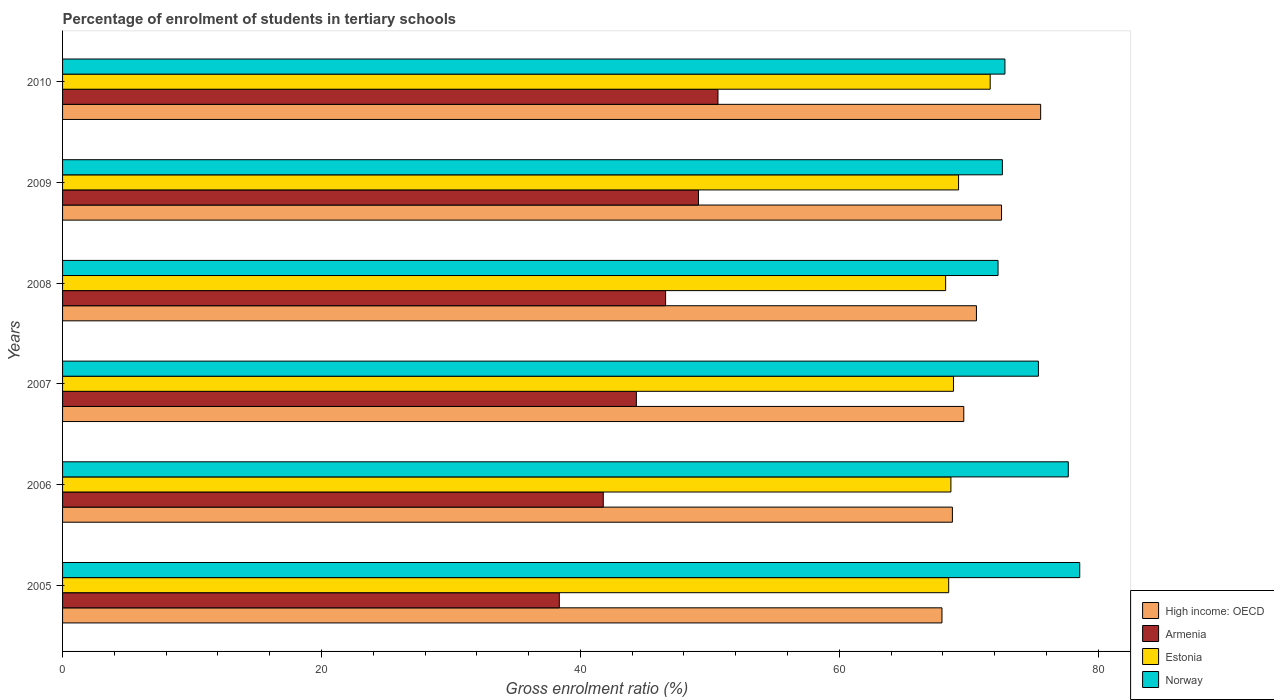How many groups of bars are there?
Provide a short and direct response. 6. Are the number of bars per tick equal to the number of legend labels?
Keep it short and to the point. Yes. Are the number of bars on each tick of the Y-axis equal?
Your answer should be compact. Yes. How many bars are there on the 6th tick from the top?
Your answer should be very brief. 4. How many bars are there on the 5th tick from the bottom?
Your answer should be very brief. 4. What is the label of the 2nd group of bars from the top?
Your answer should be very brief. 2009. In how many cases, is the number of bars for a given year not equal to the number of legend labels?
Your answer should be compact. 0. What is the percentage of students enrolled in tertiary schools in Armenia in 2008?
Your answer should be very brief. 46.58. Across all years, what is the maximum percentage of students enrolled in tertiary schools in High income: OECD?
Your answer should be very brief. 75.55. Across all years, what is the minimum percentage of students enrolled in tertiary schools in Estonia?
Ensure brevity in your answer.  68.21. In which year was the percentage of students enrolled in tertiary schools in Armenia maximum?
Your answer should be compact. 2010. In which year was the percentage of students enrolled in tertiary schools in Armenia minimum?
Keep it short and to the point. 2005. What is the total percentage of students enrolled in tertiary schools in Norway in the graph?
Keep it short and to the point. 449.27. What is the difference between the percentage of students enrolled in tertiary schools in Armenia in 2006 and that in 2009?
Make the answer very short. -7.35. What is the difference between the percentage of students enrolled in tertiary schools in Armenia in 2009 and the percentage of students enrolled in tertiary schools in Norway in 2008?
Offer a terse response. -23.14. What is the average percentage of students enrolled in tertiary schools in Estonia per year?
Provide a succinct answer. 69.16. In the year 2007, what is the difference between the percentage of students enrolled in tertiary schools in Estonia and percentage of students enrolled in tertiary schools in High income: OECD?
Your response must be concise. -0.8. In how many years, is the percentage of students enrolled in tertiary schools in High income: OECD greater than 48 %?
Make the answer very short. 6. What is the ratio of the percentage of students enrolled in tertiary schools in Norway in 2005 to that in 2006?
Your answer should be compact. 1.01. Is the percentage of students enrolled in tertiary schools in Armenia in 2008 less than that in 2009?
Your answer should be very brief. Yes. What is the difference between the highest and the second highest percentage of students enrolled in tertiary schools in High income: OECD?
Ensure brevity in your answer.  3.02. What is the difference between the highest and the lowest percentage of students enrolled in tertiary schools in High income: OECD?
Offer a terse response. 7.62. Is the sum of the percentage of students enrolled in tertiary schools in Armenia in 2006 and 2008 greater than the maximum percentage of students enrolled in tertiary schools in Norway across all years?
Offer a very short reply. Yes. Is it the case that in every year, the sum of the percentage of students enrolled in tertiary schools in Armenia and percentage of students enrolled in tertiary schools in Norway is greater than the sum of percentage of students enrolled in tertiary schools in High income: OECD and percentage of students enrolled in tertiary schools in Estonia?
Give a very brief answer. No. What does the 4th bar from the top in 2010 represents?
Provide a succinct answer. High income: OECD. What does the 3rd bar from the bottom in 2007 represents?
Keep it short and to the point. Estonia. Is it the case that in every year, the sum of the percentage of students enrolled in tertiary schools in Armenia and percentage of students enrolled in tertiary schools in Estonia is greater than the percentage of students enrolled in tertiary schools in Norway?
Give a very brief answer. Yes. How many years are there in the graph?
Provide a short and direct response. 6. Are the values on the major ticks of X-axis written in scientific E-notation?
Give a very brief answer. No. Does the graph contain any zero values?
Give a very brief answer. No. Where does the legend appear in the graph?
Keep it short and to the point. Bottom right. How many legend labels are there?
Provide a succinct answer. 4. How are the legend labels stacked?
Provide a succinct answer. Vertical. What is the title of the graph?
Offer a terse response. Percentage of enrolment of students in tertiary schools. What is the label or title of the X-axis?
Your response must be concise. Gross enrolment ratio (%). What is the Gross enrolment ratio (%) of High income: OECD in 2005?
Provide a succinct answer. 67.93. What is the Gross enrolment ratio (%) of Armenia in 2005?
Offer a terse response. 38.37. What is the Gross enrolment ratio (%) of Estonia in 2005?
Ensure brevity in your answer.  68.45. What is the Gross enrolment ratio (%) in Norway in 2005?
Ensure brevity in your answer.  78.57. What is the Gross enrolment ratio (%) of High income: OECD in 2006?
Make the answer very short. 68.73. What is the Gross enrolment ratio (%) in Armenia in 2006?
Offer a very short reply. 41.77. What is the Gross enrolment ratio (%) in Estonia in 2006?
Your answer should be very brief. 68.62. What is the Gross enrolment ratio (%) in Norway in 2006?
Give a very brief answer. 77.68. What is the Gross enrolment ratio (%) in High income: OECD in 2007?
Offer a very short reply. 69.61. What is the Gross enrolment ratio (%) in Armenia in 2007?
Ensure brevity in your answer.  44.32. What is the Gross enrolment ratio (%) of Estonia in 2007?
Offer a very short reply. 68.82. What is the Gross enrolment ratio (%) in Norway in 2007?
Provide a succinct answer. 75.38. What is the Gross enrolment ratio (%) in High income: OECD in 2008?
Ensure brevity in your answer.  70.59. What is the Gross enrolment ratio (%) in Armenia in 2008?
Make the answer very short. 46.58. What is the Gross enrolment ratio (%) of Estonia in 2008?
Your answer should be compact. 68.21. What is the Gross enrolment ratio (%) in Norway in 2008?
Your answer should be very brief. 72.26. What is the Gross enrolment ratio (%) of High income: OECD in 2009?
Offer a very short reply. 72.53. What is the Gross enrolment ratio (%) of Armenia in 2009?
Provide a succinct answer. 49.12. What is the Gross enrolment ratio (%) of Estonia in 2009?
Your answer should be compact. 69.21. What is the Gross enrolment ratio (%) in Norway in 2009?
Your response must be concise. 72.59. What is the Gross enrolment ratio (%) in High income: OECD in 2010?
Provide a short and direct response. 75.55. What is the Gross enrolment ratio (%) in Armenia in 2010?
Ensure brevity in your answer.  50.62. What is the Gross enrolment ratio (%) of Estonia in 2010?
Make the answer very short. 71.65. What is the Gross enrolment ratio (%) of Norway in 2010?
Your answer should be compact. 72.79. Across all years, what is the maximum Gross enrolment ratio (%) in High income: OECD?
Give a very brief answer. 75.55. Across all years, what is the maximum Gross enrolment ratio (%) in Armenia?
Offer a very short reply. 50.62. Across all years, what is the maximum Gross enrolment ratio (%) of Estonia?
Your answer should be compact. 71.65. Across all years, what is the maximum Gross enrolment ratio (%) of Norway?
Offer a very short reply. 78.57. Across all years, what is the minimum Gross enrolment ratio (%) of High income: OECD?
Provide a short and direct response. 67.93. Across all years, what is the minimum Gross enrolment ratio (%) in Armenia?
Provide a succinct answer. 38.37. Across all years, what is the minimum Gross enrolment ratio (%) of Estonia?
Your answer should be very brief. 68.21. Across all years, what is the minimum Gross enrolment ratio (%) in Norway?
Ensure brevity in your answer.  72.26. What is the total Gross enrolment ratio (%) of High income: OECD in the graph?
Offer a terse response. 424.94. What is the total Gross enrolment ratio (%) in Armenia in the graph?
Give a very brief answer. 270.78. What is the total Gross enrolment ratio (%) in Estonia in the graph?
Provide a succinct answer. 414.95. What is the total Gross enrolment ratio (%) in Norway in the graph?
Ensure brevity in your answer.  449.27. What is the difference between the Gross enrolment ratio (%) in High income: OECD in 2005 and that in 2006?
Offer a very short reply. -0.81. What is the difference between the Gross enrolment ratio (%) of Armenia in 2005 and that in 2006?
Provide a short and direct response. -3.4. What is the difference between the Gross enrolment ratio (%) in Estonia in 2005 and that in 2006?
Your answer should be very brief. -0.17. What is the difference between the Gross enrolment ratio (%) of Norway in 2005 and that in 2006?
Your answer should be very brief. 0.88. What is the difference between the Gross enrolment ratio (%) of High income: OECD in 2005 and that in 2007?
Offer a very short reply. -1.69. What is the difference between the Gross enrolment ratio (%) of Armenia in 2005 and that in 2007?
Keep it short and to the point. -5.95. What is the difference between the Gross enrolment ratio (%) of Estonia in 2005 and that in 2007?
Offer a terse response. -0.37. What is the difference between the Gross enrolment ratio (%) in Norway in 2005 and that in 2007?
Ensure brevity in your answer.  3.19. What is the difference between the Gross enrolment ratio (%) in High income: OECD in 2005 and that in 2008?
Offer a very short reply. -2.66. What is the difference between the Gross enrolment ratio (%) of Armenia in 2005 and that in 2008?
Provide a succinct answer. -8.21. What is the difference between the Gross enrolment ratio (%) of Estonia in 2005 and that in 2008?
Give a very brief answer. 0.24. What is the difference between the Gross enrolment ratio (%) in Norway in 2005 and that in 2008?
Your response must be concise. 6.31. What is the difference between the Gross enrolment ratio (%) in High income: OECD in 2005 and that in 2009?
Provide a succinct answer. -4.6. What is the difference between the Gross enrolment ratio (%) in Armenia in 2005 and that in 2009?
Provide a short and direct response. -10.75. What is the difference between the Gross enrolment ratio (%) of Estonia in 2005 and that in 2009?
Your answer should be very brief. -0.76. What is the difference between the Gross enrolment ratio (%) in Norway in 2005 and that in 2009?
Ensure brevity in your answer.  5.98. What is the difference between the Gross enrolment ratio (%) of High income: OECD in 2005 and that in 2010?
Provide a succinct answer. -7.62. What is the difference between the Gross enrolment ratio (%) of Armenia in 2005 and that in 2010?
Offer a very short reply. -12.26. What is the difference between the Gross enrolment ratio (%) in Estonia in 2005 and that in 2010?
Keep it short and to the point. -3.21. What is the difference between the Gross enrolment ratio (%) in Norway in 2005 and that in 2010?
Ensure brevity in your answer.  5.78. What is the difference between the Gross enrolment ratio (%) in High income: OECD in 2006 and that in 2007?
Give a very brief answer. -0.88. What is the difference between the Gross enrolment ratio (%) in Armenia in 2006 and that in 2007?
Make the answer very short. -2.56. What is the difference between the Gross enrolment ratio (%) in Estonia in 2006 and that in 2007?
Give a very brief answer. -0.2. What is the difference between the Gross enrolment ratio (%) in Norway in 2006 and that in 2007?
Offer a very short reply. 2.31. What is the difference between the Gross enrolment ratio (%) in High income: OECD in 2006 and that in 2008?
Keep it short and to the point. -1.86. What is the difference between the Gross enrolment ratio (%) in Armenia in 2006 and that in 2008?
Offer a terse response. -4.82. What is the difference between the Gross enrolment ratio (%) of Estonia in 2006 and that in 2008?
Your answer should be very brief. 0.41. What is the difference between the Gross enrolment ratio (%) of Norway in 2006 and that in 2008?
Give a very brief answer. 5.43. What is the difference between the Gross enrolment ratio (%) of High income: OECD in 2006 and that in 2009?
Keep it short and to the point. -3.8. What is the difference between the Gross enrolment ratio (%) of Armenia in 2006 and that in 2009?
Your response must be concise. -7.35. What is the difference between the Gross enrolment ratio (%) in Estonia in 2006 and that in 2009?
Your answer should be very brief. -0.59. What is the difference between the Gross enrolment ratio (%) in Norway in 2006 and that in 2009?
Offer a terse response. 5.09. What is the difference between the Gross enrolment ratio (%) in High income: OECD in 2006 and that in 2010?
Your answer should be compact. -6.82. What is the difference between the Gross enrolment ratio (%) in Armenia in 2006 and that in 2010?
Provide a short and direct response. -8.86. What is the difference between the Gross enrolment ratio (%) in Estonia in 2006 and that in 2010?
Your answer should be compact. -3.03. What is the difference between the Gross enrolment ratio (%) of Norway in 2006 and that in 2010?
Offer a very short reply. 4.89. What is the difference between the Gross enrolment ratio (%) in High income: OECD in 2007 and that in 2008?
Your answer should be compact. -0.98. What is the difference between the Gross enrolment ratio (%) of Armenia in 2007 and that in 2008?
Keep it short and to the point. -2.26. What is the difference between the Gross enrolment ratio (%) in Estonia in 2007 and that in 2008?
Keep it short and to the point. 0.6. What is the difference between the Gross enrolment ratio (%) in Norway in 2007 and that in 2008?
Give a very brief answer. 3.12. What is the difference between the Gross enrolment ratio (%) of High income: OECD in 2007 and that in 2009?
Offer a very short reply. -2.92. What is the difference between the Gross enrolment ratio (%) in Armenia in 2007 and that in 2009?
Make the answer very short. -4.8. What is the difference between the Gross enrolment ratio (%) in Estonia in 2007 and that in 2009?
Ensure brevity in your answer.  -0.39. What is the difference between the Gross enrolment ratio (%) in Norway in 2007 and that in 2009?
Make the answer very short. 2.78. What is the difference between the Gross enrolment ratio (%) in High income: OECD in 2007 and that in 2010?
Offer a very short reply. -5.94. What is the difference between the Gross enrolment ratio (%) of Armenia in 2007 and that in 2010?
Keep it short and to the point. -6.3. What is the difference between the Gross enrolment ratio (%) of Estonia in 2007 and that in 2010?
Ensure brevity in your answer.  -2.84. What is the difference between the Gross enrolment ratio (%) of Norway in 2007 and that in 2010?
Offer a terse response. 2.59. What is the difference between the Gross enrolment ratio (%) in High income: OECD in 2008 and that in 2009?
Your response must be concise. -1.94. What is the difference between the Gross enrolment ratio (%) in Armenia in 2008 and that in 2009?
Ensure brevity in your answer.  -2.54. What is the difference between the Gross enrolment ratio (%) in Estonia in 2008 and that in 2009?
Your answer should be very brief. -1. What is the difference between the Gross enrolment ratio (%) of Norway in 2008 and that in 2009?
Offer a very short reply. -0.33. What is the difference between the Gross enrolment ratio (%) of High income: OECD in 2008 and that in 2010?
Make the answer very short. -4.96. What is the difference between the Gross enrolment ratio (%) of Armenia in 2008 and that in 2010?
Keep it short and to the point. -4.04. What is the difference between the Gross enrolment ratio (%) of Estonia in 2008 and that in 2010?
Your answer should be very brief. -3.44. What is the difference between the Gross enrolment ratio (%) of Norway in 2008 and that in 2010?
Provide a succinct answer. -0.53. What is the difference between the Gross enrolment ratio (%) of High income: OECD in 2009 and that in 2010?
Your response must be concise. -3.02. What is the difference between the Gross enrolment ratio (%) in Armenia in 2009 and that in 2010?
Your response must be concise. -1.5. What is the difference between the Gross enrolment ratio (%) in Estonia in 2009 and that in 2010?
Provide a succinct answer. -2.44. What is the difference between the Gross enrolment ratio (%) of Norway in 2009 and that in 2010?
Offer a terse response. -0.2. What is the difference between the Gross enrolment ratio (%) in High income: OECD in 2005 and the Gross enrolment ratio (%) in Armenia in 2006?
Offer a terse response. 26.16. What is the difference between the Gross enrolment ratio (%) in High income: OECD in 2005 and the Gross enrolment ratio (%) in Estonia in 2006?
Your answer should be very brief. -0.69. What is the difference between the Gross enrolment ratio (%) in High income: OECD in 2005 and the Gross enrolment ratio (%) in Norway in 2006?
Provide a short and direct response. -9.76. What is the difference between the Gross enrolment ratio (%) of Armenia in 2005 and the Gross enrolment ratio (%) of Estonia in 2006?
Make the answer very short. -30.25. What is the difference between the Gross enrolment ratio (%) in Armenia in 2005 and the Gross enrolment ratio (%) in Norway in 2006?
Your response must be concise. -39.31. What is the difference between the Gross enrolment ratio (%) of Estonia in 2005 and the Gross enrolment ratio (%) of Norway in 2006?
Provide a short and direct response. -9.24. What is the difference between the Gross enrolment ratio (%) of High income: OECD in 2005 and the Gross enrolment ratio (%) of Armenia in 2007?
Make the answer very short. 23.6. What is the difference between the Gross enrolment ratio (%) in High income: OECD in 2005 and the Gross enrolment ratio (%) in Estonia in 2007?
Your answer should be very brief. -0.89. What is the difference between the Gross enrolment ratio (%) of High income: OECD in 2005 and the Gross enrolment ratio (%) of Norway in 2007?
Offer a very short reply. -7.45. What is the difference between the Gross enrolment ratio (%) in Armenia in 2005 and the Gross enrolment ratio (%) in Estonia in 2007?
Your response must be concise. -30.45. What is the difference between the Gross enrolment ratio (%) in Armenia in 2005 and the Gross enrolment ratio (%) in Norway in 2007?
Keep it short and to the point. -37.01. What is the difference between the Gross enrolment ratio (%) of Estonia in 2005 and the Gross enrolment ratio (%) of Norway in 2007?
Ensure brevity in your answer.  -6.93. What is the difference between the Gross enrolment ratio (%) in High income: OECD in 2005 and the Gross enrolment ratio (%) in Armenia in 2008?
Offer a very short reply. 21.35. What is the difference between the Gross enrolment ratio (%) of High income: OECD in 2005 and the Gross enrolment ratio (%) of Estonia in 2008?
Ensure brevity in your answer.  -0.28. What is the difference between the Gross enrolment ratio (%) in High income: OECD in 2005 and the Gross enrolment ratio (%) in Norway in 2008?
Offer a terse response. -4.33. What is the difference between the Gross enrolment ratio (%) in Armenia in 2005 and the Gross enrolment ratio (%) in Estonia in 2008?
Make the answer very short. -29.84. What is the difference between the Gross enrolment ratio (%) in Armenia in 2005 and the Gross enrolment ratio (%) in Norway in 2008?
Give a very brief answer. -33.89. What is the difference between the Gross enrolment ratio (%) of Estonia in 2005 and the Gross enrolment ratio (%) of Norway in 2008?
Your response must be concise. -3.81. What is the difference between the Gross enrolment ratio (%) of High income: OECD in 2005 and the Gross enrolment ratio (%) of Armenia in 2009?
Provide a succinct answer. 18.81. What is the difference between the Gross enrolment ratio (%) in High income: OECD in 2005 and the Gross enrolment ratio (%) in Estonia in 2009?
Your response must be concise. -1.28. What is the difference between the Gross enrolment ratio (%) of High income: OECD in 2005 and the Gross enrolment ratio (%) of Norway in 2009?
Offer a very short reply. -4.67. What is the difference between the Gross enrolment ratio (%) of Armenia in 2005 and the Gross enrolment ratio (%) of Estonia in 2009?
Your answer should be very brief. -30.84. What is the difference between the Gross enrolment ratio (%) of Armenia in 2005 and the Gross enrolment ratio (%) of Norway in 2009?
Give a very brief answer. -34.22. What is the difference between the Gross enrolment ratio (%) in Estonia in 2005 and the Gross enrolment ratio (%) in Norway in 2009?
Offer a very short reply. -4.15. What is the difference between the Gross enrolment ratio (%) of High income: OECD in 2005 and the Gross enrolment ratio (%) of Armenia in 2010?
Make the answer very short. 17.3. What is the difference between the Gross enrolment ratio (%) of High income: OECD in 2005 and the Gross enrolment ratio (%) of Estonia in 2010?
Provide a short and direct response. -3.72. What is the difference between the Gross enrolment ratio (%) of High income: OECD in 2005 and the Gross enrolment ratio (%) of Norway in 2010?
Ensure brevity in your answer.  -4.86. What is the difference between the Gross enrolment ratio (%) in Armenia in 2005 and the Gross enrolment ratio (%) in Estonia in 2010?
Provide a succinct answer. -33.28. What is the difference between the Gross enrolment ratio (%) in Armenia in 2005 and the Gross enrolment ratio (%) in Norway in 2010?
Offer a terse response. -34.42. What is the difference between the Gross enrolment ratio (%) of Estonia in 2005 and the Gross enrolment ratio (%) of Norway in 2010?
Ensure brevity in your answer.  -4.35. What is the difference between the Gross enrolment ratio (%) in High income: OECD in 2006 and the Gross enrolment ratio (%) in Armenia in 2007?
Your answer should be compact. 24.41. What is the difference between the Gross enrolment ratio (%) of High income: OECD in 2006 and the Gross enrolment ratio (%) of Estonia in 2007?
Your answer should be compact. -0.08. What is the difference between the Gross enrolment ratio (%) of High income: OECD in 2006 and the Gross enrolment ratio (%) of Norway in 2007?
Make the answer very short. -6.64. What is the difference between the Gross enrolment ratio (%) of Armenia in 2006 and the Gross enrolment ratio (%) of Estonia in 2007?
Offer a very short reply. -27.05. What is the difference between the Gross enrolment ratio (%) of Armenia in 2006 and the Gross enrolment ratio (%) of Norway in 2007?
Offer a very short reply. -33.61. What is the difference between the Gross enrolment ratio (%) of Estonia in 2006 and the Gross enrolment ratio (%) of Norway in 2007?
Keep it short and to the point. -6.76. What is the difference between the Gross enrolment ratio (%) of High income: OECD in 2006 and the Gross enrolment ratio (%) of Armenia in 2008?
Keep it short and to the point. 22.15. What is the difference between the Gross enrolment ratio (%) in High income: OECD in 2006 and the Gross enrolment ratio (%) in Estonia in 2008?
Provide a succinct answer. 0.52. What is the difference between the Gross enrolment ratio (%) in High income: OECD in 2006 and the Gross enrolment ratio (%) in Norway in 2008?
Make the answer very short. -3.53. What is the difference between the Gross enrolment ratio (%) in Armenia in 2006 and the Gross enrolment ratio (%) in Estonia in 2008?
Your response must be concise. -26.45. What is the difference between the Gross enrolment ratio (%) in Armenia in 2006 and the Gross enrolment ratio (%) in Norway in 2008?
Your answer should be compact. -30.49. What is the difference between the Gross enrolment ratio (%) in Estonia in 2006 and the Gross enrolment ratio (%) in Norway in 2008?
Make the answer very short. -3.64. What is the difference between the Gross enrolment ratio (%) in High income: OECD in 2006 and the Gross enrolment ratio (%) in Armenia in 2009?
Give a very brief answer. 19.61. What is the difference between the Gross enrolment ratio (%) of High income: OECD in 2006 and the Gross enrolment ratio (%) of Estonia in 2009?
Your response must be concise. -0.48. What is the difference between the Gross enrolment ratio (%) in High income: OECD in 2006 and the Gross enrolment ratio (%) in Norway in 2009?
Give a very brief answer. -3.86. What is the difference between the Gross enrolment ratio (%) of Armenia in 2006 and the Gross enrolment ratio (%) of Estonia in 2009?
Give a very brief answer. -27.44. What is the difference between the Gross enrolment ratio (%) in Armenia in 2006 and the Gross enrolment ratio (%) in Norway in 2009?
Offer a terse response. -30.83. What is the difference between the Gross enrolment ratio (%) of Estonia in 2006 and the Gross enrolment ratio (%) of Norway in 2009?
Make the answer very short. -3.98. What is the difference between the Gross enrolment ratio (%) of High income: OECD in 2006 and the Gross enrolment ratio (%) of Armenia in 2010?
Provide a short and direct response. 18.11. What is the difference between the Gross enrolment ratio (%) of High income: OECD in 2006 and the Gross enrolment ratio (%) of Estonia in 2010?
Your answer should be very brief. -2.92. What is the difference between the Gross enrolment ratio (%) of High income: OECD in 2006 and the Gross enrolment ratio (%) of Norway in 2010?
Offer a terse response. -4.06. What is the difference between the Gross enrolment ratio (%) in Armenia in 2006 and the Gross enrolment ratio (%) in Estonia in 2010?
Ensure brevity in your answer.  -29.89. What is the difference between the Gross enrolment ratio (%) in Armenia in 2006 and the Gross enrolment ratio (%) in Norway in 2010?
Provide a succinct answer. -31.03. What is the difference between the Gross enrolment ratio (%) of Estonia in 2006 and the Gross enrolment ratio (%) of Norway in 2010?
Your answer should be compact. -4.17. What is the difference between the Gross enrolment ratio (%) in High income: OECD in 2007 and the Gross enrolment ratio (%) in Armenia in 2008?
Your response must be concise. 23.03. What is the difference between the Gross enrolment ratio (%) in High income: OECD in 2007 and the Gross enrolment ratio (%) in Estonia in 2008?
Offer a terse response. 1.4. What is the difference between the Gross enrolment ratio (%) of High income: OECD in 2007 and the Gross enrolment ratio (%) of Norway in 2008?
Offer a terse response. -2.65. What is the difference between the Gross enrolment ratio (%) of Armenia in 2007 and the Gross enrolment ratio (%) of Estonia in 2008?
Your answer should be very brief. -23.89. What is the difference between the Gross enrolment ratio (%) in Armenia in 2007 and the Gross enrolment ratio (%) in Norway in 2008?
Your response must be concise. -27.94. What is the difference between the Gross enrolment ratio (%) in Estonia in 2007 and the Gross enrolment ratio (%) in Norway in 2008?
Keep it short and to the point. -3.44. What is the difference between the Gross enrolment ratio (%) of High income: OECD in 2007 and the Gross enrolment ratio (%) of Armenia in 2009?
Provide a succinct answer. 20.49. What is the difference between the Gross enrolment ratio (%) in High income: OECD in 2007 and the Gross enrolment ratio (%) in Estonia in 2009?
Give a very brief answer. 0.4. What is the difference between the Gross enrolment ratio (%) in High income: OECD in 2007 and the Gross enrolment ratio (%) in Norway in 2009?
Offer a very short reply. -2.98. What is the difference between the Gross enrolment ratio (%) of Armenia in 2007 and the Gross enrolment ratio (%) of Estonia in 2009?
Your answer should be compact. -24.89. What is the difference between the Gross enrolment ratio (%) in Armenia in 2007 and the Gross enrolment ratio (%) in Norway in 2009?
Your response must be concise. -28.27. What is the difference between the Gross enrolment ratio (%) in Estonia in 2007 and the Gross enrolment ratio (%) in Norway in 2009?
Offer a very short reply. -3.78. What is the difference between the Gross enrolment ratio (%) in High income: OECD in 2007 and the Gross enrolment ratio (%) in Armenia in 2010?
Ensure brevity in your answer.  18.99. What is the difference between the Gross enrolment ratio (%) of High income: OECD in 2007 and the Gross enrolment ratio (%) of Estonia in 2010?
Your answer should be very brief. -2.04. What is the difference between the Gross enrolment ratio (%) of High income: OECD in 2007 and the Gross enrolment ratio (%) of Norway in 2010?
Provide a succinct answer. -3.18. What is the difference between the Gross enrolment ratio (%) in Armenia in 2007 and the Gross enrolment ratio (%) in Estonia in 2010?
Your answer should be very brief. -27.33. What is the difference between the Gross enrolment ratio (%) in Armenia in 2007 and the Gross enrolment ratio (%) in Norway in 2010?
Provide a short and direct response. -28.47. What is the difference between the Gross enrolment ratio (%) of Estonia in 2007 and the Gross enrolment ratio (%) of Norway in 2010?
Your answer should be compact. -3.98. What is the difference between the Gross enrolment ratio (%) of High income: OECD in 2008 and the Gross enrolment ratio (%) of Armenia in 2009?
Offer a terse response. 21.47. What is the difference between the Gross enrolment ratio (%) in High income: OECD in 2008 and the Gross enrolment ratio (%) in Estonia in 2009?
Your answer should be very brief. 1.38. What is the difference between the Gross enrolment ratio (%) of High income: OECD in 2008 and the Gross enrolment ratio (%) of Norway in 2009?
Provide a succinct answer. -2. What is the difference between the Gross enrolment ratio (%) of Armenia in 2008 and the Gross enrolment ratio (%) of Estonia in 2009?
Your response must be concise. -22.63. What is the difference between the Gross enrolment ratio (%) of Armenia in 2008 and the Gross enrolment ratio (%) of Norway in 2009?
Your response must be concise. -26.01. What is the difference between the Gross enrolment ratio (%) of Estonia in 2008 and the Gross enrolment ratio (%) of Norway in 2009?
Your answer should be compact. -4.38. What is the difference between the Gross enrolment ratio (%) in High income: OECD in 2008 and the Gross enrolment ratio (%) in Armenia in 2010?
Your response must be concise. 19.96. What is the difference between the Gross enrolment ratio (%) of High income: OECD in 2008 and the Gross enrolment ratio (%) of Estonia in 2010?
Provide a succinct answer. -1.06. What is the difference between the Gross enrolment ratio (%) of High income: OECD in 2008 and the Gross enrolment ratio (%) of Norway in 2010?
Offer a terse response. -2.2. What is the difference between the Gross enrolment ratio (%) of Armenia in 2008 and the Gross enrolment ratio (%) of Estonia in 2010?
Your response must be concise. -25.07. What is the difference between the Gross enrolment ratio (%) of Armenia in 2008 and the Gross enrolment ratio (%) of Norway in 2010?
Ensure brevity in your answer.  -26.21. What is the difference between the Gross enrolment ratio (%) of Estonia in 2008 and the Gross enrolment ratio (%) of Norway in 2010?
Your answer should be very brief. -4.58. What is the difference between the Gross enrolment ratio (%) of High income: OECD in 2009 and the Gross enrolment ratio (%) of Armenia in 2010?
Your answer should be very brief. 21.9. What is the difference between the Gross enrolment ratio (%) of High income: OECD in 2009 and the Gross enrolment ratio (%) of Estonia in 2010?
Provide a succinct answer. 0.88. What is the difference between the Gross enrolment ratio (%) of High income: OECD in 2009 and the Gross enrolment ratio (%) of Norway in 2010?
Offer a terse response. -0.26. What is the difference between the Gross enrolment ratio (%) of Armenia in 2009 and the Gross enrolment ratio (%) of Estonia in 2010?
Provide a succinct answer. -22.53. What is the difference between the Gross enrolment ratio (%) of Armenia in 2009 and the Gross enrolment ratio (%) of Norway in 2010?
Keep it short and to the point. -23.67. What is the difference between the Gross enrolment ratio (%) of Estonia in 2009 and the Gross enrolment ratio (%) of Norway in 2010?
Make the answer very short. -3.58. What is the average Gross enrolment ratio (%) in High income: OECD per year?
Provide a succinct answer. 70.82. What is the average Gross enrolment ratio (%) in Armenia per year?
Offer a terse response. 45.13. What is the average Gross enrolment ratio (%) of Estonia per year?
Your answer should be very brief. 69.16. What is the average Gross enrolment ratio (%) of Norway per year?
Provide a short and direct response. 74.88. In the year 2005, what is the difference between the Gross enrolment ratio (%) of High income: OECD and Gross enrolment ratio (%) of Armenia?
Offer a terse response. 29.56. In the year 2005, what is the difference between the Gross enrolment ratio (%) of High income: OECD and Gross enrolment ratio (%) of Estonia?
Provide a short and direct response. -0.52. In the year 2005, what is the difference between the Gross enrolment ratio (%) of High income: OECD and Gross enrolment ratio (%) of Norway?
Ensure brevity in your answer.  -10.64. In the year 2005, what is the difference between the Gross enrolment ratio (%) of Armenia and Gross enrolment ratio (%) of Estonia?
Provide a short and direct response. -30.08. In the year 2005, what is the difference between the Gross enrolment ratio (%) in Armenia and Gross enrolment ratio (%) in Norway?
Keep it short and to the point. -40.2. In the year 2005, what is the difference between the Gross enrolment ratio (%) of Estonia and Gross enrolment ratio (%) of Norway?
Provide a short and direct response. -10.12. In the year 2006, what is the difference between the Gross enrolment ratio (%) in High income: OECD and Gross enrolment ratio (%) in Armenia?
Your answer should be compact. 26.97. In the year 2006, what is the difference between the Gross enrolment ratio (%) in High income: OECD and Gross enrolment ratio (%) in Estonia?
Provide a succinct answer. 0.11. In the year 2006, what is the difference between the Gross enrolment ratio (%) in High income: OECD and Gross enrolment ratio (%) in Norway?
Your answer should be very brief. -8.95. In the year 2006, what is the difference between the Gross enrolment ratio (%) in Armenia and Gross enrolment ratio (%) in Estonia?
Provide a succinct answer. -26.85. In the year 2006, what is the difference between the Gross enrolment ratio (%) of Armenia and Gross enrolment ratio (%) of Norway?
Ensure brevity in your answer.  -35.92. In the year 2006, what is the difference between the Gross enrolment ratio (%) in Estonia and Gross enrolment ratio (%) in Norway?
Give a very brief answer. -9.07. In the year 2007, what is the difference between the Gross enrolment ratio (%) in High income: OECD and Gross enrolment ratio (%) in Armenia?
Your answer should be compact. 25.29. In the year 2007, what is the difference between the Gross enrolment ratio (%) in High income: OECD and Gross enrolment ratio (%) in Estonia?
Provide a succinct answer. 0.8. In the year 2007, what is the difference between the Gross enrolment ratio (%) of High income: OECD and Gross enrolment ratio (%) of Norway?
Make the answer very short. -5.77. In the year 2007, what is the difference between the Gross enrolment ratio (%) in Armenia and Gross enrolment ratio (%) in Estonia?
Provide a succinct answer. -24.49. In the year 2007, what is the difference between the Gross enrolment ratio (%) in Armenia and Gross enrolment ratio (%) in Norway?
Ensure brevity in your answer.  -31.05. In the year 2007, what is the difference between the Gross enrolment ratio (%) of Estonia and Gross enrolment ratio (%) of Norway?
Your response must be concise. -6.56. In the year 2008, what is the difference between the Gross enrolment ratio (%) in High income: OECD and Gross enrolment ratio (%) in Armenia?
Your answer should be very brief. 24.01. In the year 2008, what is the difference between the Gross enrolment ratio (%) in High income: OECD and Gross enrolment ratio (%) in Estonia?
Ensure brevity in your answer.  2.38. In the year 2008, what is the difference between the Gross enrolment ratio (%) of High income: OECD and Gross enrolment ratio (%) of Norway?
Your answer should be very brief. -1.67. In the year 2008, what is the difference between the Gross enrolment ratio (%) in Armenia and Gross enrolment ratio (%) in Estonia?
Give a very brief answer. -21.63. In the year 2008, what is the difference between the Gross enrolment ratio (%) in Armenia and Gross enrolment ratio (%) in Norway?
Keep it short and to the point. -25.68. In the year 2008, what is the difference between the Gross enrolment ratio (%) of Estonia and Gross enrolment ratio (%) of Norway?
Ensure brevity in your answer.  -4.05. In the year 2009, what is the difference between the Gross enrolment ratio (%) in High income: OECD and Gross enrolment ratio (%) in Armenia?
Ensure brevity in your answer.  23.41. In the year 2009, what is the difference between the Gross enrolment ratio (%) of High income: OECD and Gross enrolment ratio (%) of Estonia?
Make the answer very short. 3.32. In the year 2009, what is the difference between the Gross enrolment ratio (%) in High income: OECD and Gross enrolment ratio (%) in Norway?
Provide a succinct answer. -0.06. In the year 2009, what is the difference between the Gross enrolment ratio (%) in Armenia and Gross enrolment ratio (%) in Estonia?
Your answer should be compact. -20.09. In the year 2009, what is the difference between the Gross enrolment ratio (%) in Armenia and Gross enrolment ratio (%) in Norway?
Your response must be concise. -23.47. In the year 2009, what is the difference between the Gross enrolment ratio (%) in Estonia and Gross enrolment ratio (%) in Norway?
Your answer should be compact. -3.38. In the year 2010, what is the difference between the Gross enrolment ratio (%) of High income: OECD and Gross enrolment ratio (%) of Armenia?
Provide a short and direct response. 24.93. In the year 2010, what is the difference between the Gross enrolment ratio (%) in High income: OECD and Gross enrolment ratio (%) in Estonia?
Make the answer very short. 3.9. In the year 2010, what is the difference between the Gross enrolment ratio (%) of High income: OECD and Gross enrolment ratio (%) of Norway?
Give a very brief answer. 2.76. In the year 2010, what is the difference between the Gross enrolment ratio (%) in Armenia and Gross enrolment ratio (%) in Estonia?
Your answer should be very brief. -21.03. In the year 2010, what is the difference between the Gross enrolment ratio (%) in Armenia and Gross enrolment ratio (%) in Norway?
Your answer should be very brief. -22.17. In the year 2010, what is the difference between the Gross enrolment ratio (%) in Estonia and Gross enrolment ratio (%) in Norway?
Your answer should be compact. -1.14. What is the ratio of the Gross enrolment ratio (%) of High income: OECD in 2005 to that in 2006?
Offer a terse response. 0.99. What is the ratio of the Gross enrolment ratio (%) of Armenia in 2005 to that in 2006?
Offer a very short reply. 0.92. What is the ratio of the Gross enrolment ratio (%) of Estonia in 2005 to that in 2006?
Offer a very short reply. 1. What is the ratio of the Gross enrolment ratio (%) of Norway in 2005 to that in 2006?
Give a very brief answer. 1.01. What is the ratio of the Gross enrolment ratio (%) in High income: OECD in 2005 to that in 2007?
Your response must be concise. 0.98. What is the ratio of the Gross enrolment ratio (%) of Armenia in 2005 to that in 2007?
Provide a succinct answer. 0.87. What is the ratio of the Gross enrolment ratio (%) in Norway in 2005 to that in 2007?
Give a very brief answer. 1.04. What is the ratio of the Gross enrolment ratio (%) in High income: OECD in 2005 to that in 2008?
Ensure brevity in your answer.  0.96. What is the ratio of the Gross enrolment ratio (%) of Armenia in 2005 to that in 2008?
Offer a very short reply. 0.82. What is the ratio of the Gross enrolment ratio (%) of Norway in 2005 to that in 2008?
Make the answer very short. 1.09. What is the ratio of the Gross enrolment ratio (%) in High income: OECD in 2005 to that in 2009?
Offer a very short reply. 0.94. What is the ratio of the Gross enrolment ratio (%) in Armenia in 2005 to that in 2009?
Offer a terse response. 0.78. What is the ratio of the Gross enrolment ratio (%) of Norway in 2005 to that in 2009?
Provide a short and direct response. 1.08. What is the ratio of the Gross enrolment ratio (%) in High income: OECD in 2005 to that in 2010?
Offer a very short reply. 0.9. What is the ratio of the Gross enrolment ratio (%) of Armenia in 2005 to that in 2010?
Provide a short and direct response. 0.76. What is the ratio of the Gross enrolment ratio (%) in Estonia in 2005 to that in 2010?
Offer a terse response. 0.96. What is the ratio of the Gross enrolment ratio (%) of Norway in 2005 to that in 2010?
Offer a terse response. 1.08. What is the ratio of the Gross enrolment ratio (%) in High income: OECD in 2006 to that in 2007?
Your response must be concise. 0.99. What is the ratio of the Gross enrolment ratio (%) in Armenia in 2006 to that in 2007?
Give a very brief answer. 0.94. What is the ratio of the Gross enrolment ratio (%) in Norway in 2006 to that in 2007?
Ensure brevity in your answer.  1.03. What is the ratio of the Gross enrolment ratio (%) of High income: OECD in 2006 to that in 2008?
Keep it short and to the point. 0.97. What is the ratio of the Gross enrolment ratio (%) of Armenia in 2006 to that in 2008?
Provide a succinct answer. 0.9. What is the ratio of the Gross enrolment ratio (%) of Norway in 2006 to that in 2008?
Keep it short and to the point. 1.08. What is the ratio of the Gross enrolment ratio (%) of High income: OECD in 2006 to that in 2009?
Provide a short and direct response. 0.95. What is the ratio of the Gross enrolment ratio (%) of Armenia in 2006 to that in 2009?
Your response must be concise. 0.85. What is the ratio of the Gross enrolment ratio (%) of Estonia in 2006 to that in 2009?
Offer a very short reply. 0.99. What is the ratio of the Gross enrolment ratio (%) in Norway in 2006 to that in 2009?
Provide a succinct answer. 1.07. What is the ratio of the Gross enrolment ratio (%) of High income: OECD in 2006 to that in 2010?
Offer a terse response. 0.91. What is the ratio of the Gross enrolment ratio (%) in Armenia in 2006 to that in 2010?
Provide a succinct answer. 0.82. What is the ratio of the Gross enrolment ratio (%) of Estonia in 2006 to that in 2010?
Your response must be concise. 0.96. What is the ratio of the Gross enrolment ratio (%) of Norway in 2006 to that in 2010?
Make the answer very short. 1.07. What is the ratio of the Gross enrolment ratio (%) of High income: OECD in 2007 to that in 2008?
Give a very brief answer. 0.99. What is the ratio of the Gross enrolment ratio (%) in Armenia in 2007 to that in 2008?
Offer a terse response. 0.95. What is the ratio of the Gross enrolment ratio (%) in Estonia in 2007 to that in 2008?
Your response must be concise. 1.01. What is the ratio of the Gross enrolment ratio (%) of Norway in 2007 to that in 2008?
Provide a short and direct response. 1.04. What is the ratio of the Gross enrolment ratio (%) in High income: OECD in 2007 to that in 2009?
Provide a succinct answer. 0.96. What is the ratio of the Gross enrolment ratio (%) in Armenia in 2007 to that in 2009?
Your response must be concise. 0.9. What is the ratio of the Gross enrolment ratio (%) in Estonia in 2007 to that in 2009?
Your answer should be very brief. 0.99. What is the ratio of the Gross enrolment ratio (%) of Norway in 2007 to that in 2009?
Your answer should be compact. 1.04. What is the ratio of the Gross enrolment ratio (%) in High income: OECD in 2007 to that in 2010?
Offer a very short reply. 0.92. What is the ratio of the Gross enrolment ratio (%) in Armenia in 2007 to that in 2010?
Provide a short and direct response. 0.88. What is the ratio of the Gross enrolment ratio (%) of Estonia in 2007 to that in 2010?
Your answer should be very brief. 0.96. What is the ratio of the Gross enrolment ratio (%) of Norway in 2007 to that in 2010?
Offer a terse response. 1.04. What is the ratio of the Gross enrolment ratio (%) of High income: OECD in 2008 to that in 2009?
Provide a succinct answer. 0.97. What is the ratio of the Gross enrolment ratio (%) in Armenia in 2008 to that in 2009?
Make the answer very short. 0.95. What is the ratio of the Gross enrolment ratio (%) of Estonia in 2008 to that in 2009?
Make the answer very short. 0.99. What is the ratio of the Gross enrolment ratio (%) in High income: OECD in 2008 to that in 2010?
Make the answer very short. 0.93. What is the ratio of the Gross enrolment ratio (%) in Armenia in 2008 to that in 2010?
Provide a succinct answer. 0.92. What is the ratio of the Gross enrolment ratio (%) of Armenia in 2009 to that in 2010?
Your answer should be very brief. 0.97. What is the ratio of the Gross enrolment ratio (%) of Estonia in 2009 to that in 2010?
Provide a short and direct response. 0.97. What is the difference between the highest and the second highest Gross enrolment ratio (%) of High income: OECD?
Give a very brief answer. 3.02. What is the difference between the highest and the second highest Gross enrolment ratio (%) in Armenia?
Offer a terse response. 1.5. What is the difference between the highest and the second highest Gross enrolment ratio (%) in Estonia?
Your answer should be compact. 2.44. What is the difference between the highest and the second highest Gross enrolment ratio (%) in Norway?
Provide a succinct answer. 0.88. What is the difference between the highest and the lowest Gross enrolment ratio (%) of High income: OECD?
Provide a short and direct response. 7.62. What is the difference between the highest and the lowest Gross enrolment ratio (%) of Armenia?
Provide a succinct answer. 12.26. What is the difference between the highest and the lowest Gross enrolment ratio (%) in Estonia?
Provide a succinct answer. 3.44. What is the difference between the highest and the lowest Gross enrolment ratio (%) of Norway?
Make the answer very short. 6.31. 